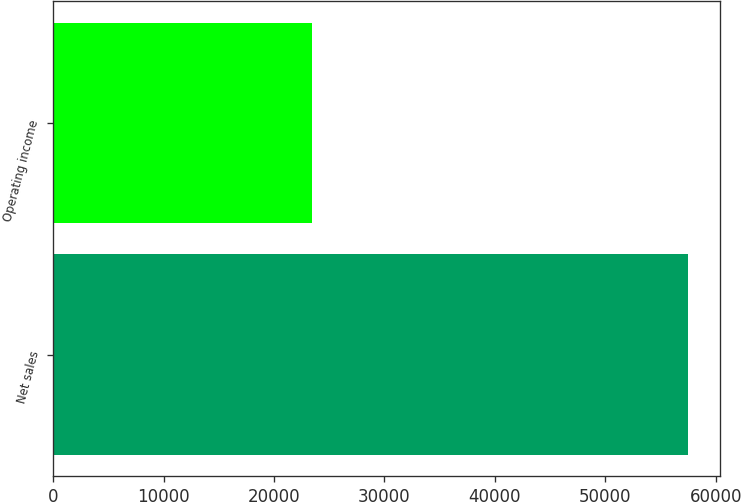Convert chart. <chart><loc_0><loc_0><loc_500><loc_500><bar_chart><fcel>Net sales<fcel>Operating income<nl><fcel>57512<fcel>23414<nl></chart> 